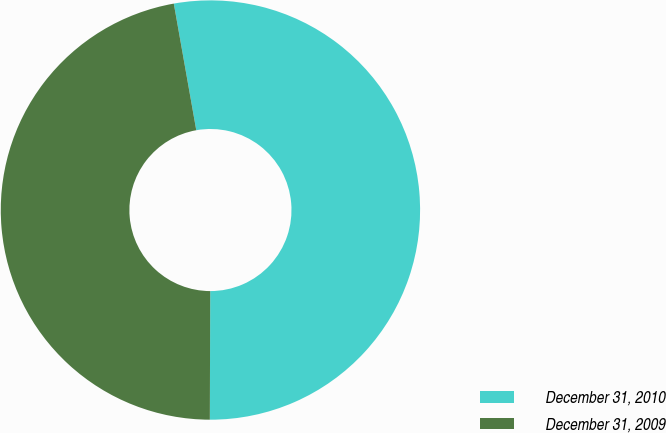Convert chart. <chart><loc_0><loc_0><loc_500><loc_500><pie_chart><fcel>December 31, 2010<fcel>December 31, 2009<nl><fcel>52.84%<fcel>47.16%<nl></chart> 